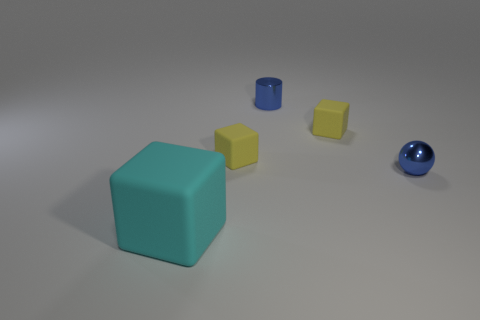What is the size of the ball that is the same material as the small blue cylinder?
Offer a terse response. Small. What number of cyan matte cubes have the same size as the blue sphere?
Ensure brevity in your answer.  0. There is a ball that is the same color as the small cylinder; what size is it?
Ensure brevity in your answer.  Small. What color is the cube that is in front of the tiny blue object that is to the right of the small blue shiny cylinder?
Your answer should be very brief. Cyan. Is there a tiny sphere of the same color as the tiny cylinder?
Your answer should be very brief. Yes. The shiny object that is the same size as the metallic cylinder is what color?
Give a very brief answer. Blue. Do the blue cylinder behind the tiny ball and the sphere have the same material?
Your answer should be very brief. Yes. There is a yellow object on the left side of the tiny blue thing that is left of the tiny blue shiny sphere; are there any yellow objects that are behind it?
Give a very brief answer. Yes. There is a rubber object that is right of the tiny metallic cylinder; is its shape the same as the large cyan thing?
Offer a terse response. Yes. What shape is the large thing in front of the metal object behind the metal sphere?
Provide a succinct answer. Cube. 